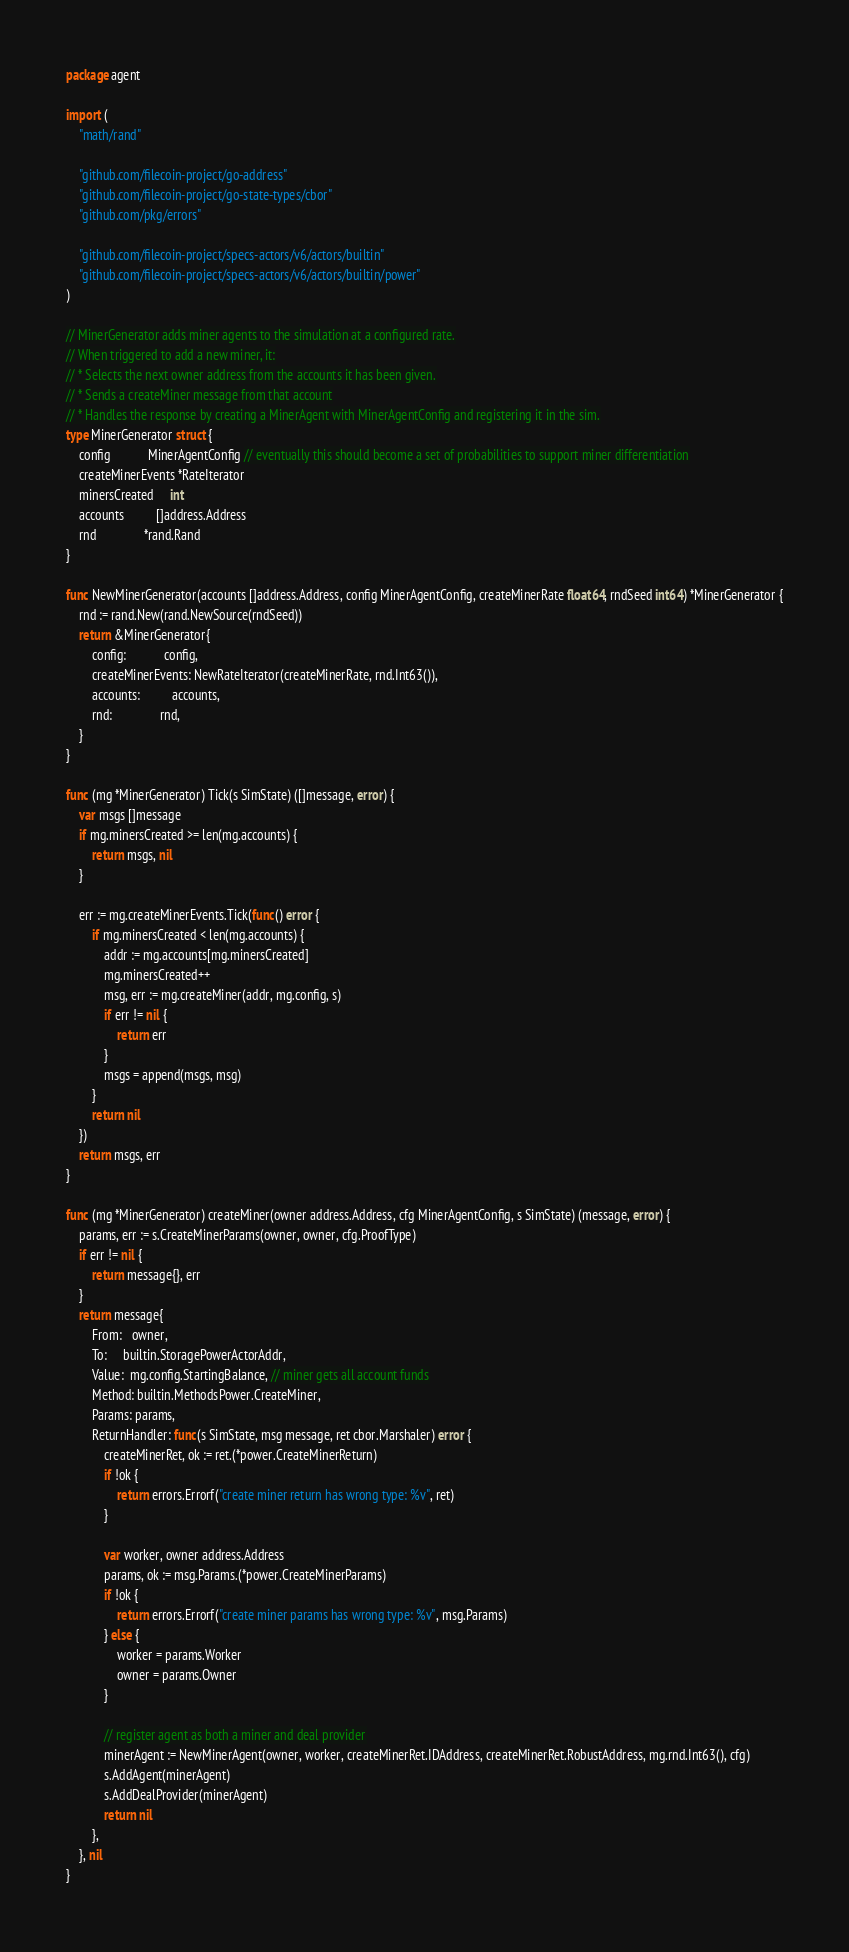Convert code to text. <code><loc_0><loc_0><loc_500><loc_500><_Go_>package agent

import (
	"math/rand"

	"github.com/filecoin-project/go-address"
	"github.com/filecoin-project/go-state-types/cbor"
	"github.com/pkg/errors"

	"github.com/filecoin-project/specs-actors/v6/actors/builtin"
	"github.com/filecoin-project/specs-actors/v6/actors/builtin/power"
)

// MinerGenerator adds miner agents to the simulation at a configured rate.
// When triggered to add a new miner, it:
// * Selects the next owner address from the accounts it has been given.
// * Sends a createMiner message from that account
// * Handles the response by creating a MinerAgent with MinerAgentConfig and registering it in the sim.
type MinerGenerator struct {
	config            MinerAgentConfig // eventually this should become a set of probabilities to support miner differentiation
	createMinerEvents *RateIterator
	minersCreated     int
	accounts          []address.Address
	rnd               *rand.Rand
}

func NewMinerGenerator(accounts []address.Address, config MinerAgentConfig, createMinerRate float64, rndSeed int64) *MinerGenerator {
	rnd := rand.New(rand.NewSource(rndSeed))
	return &MinerGenerator{
		config:            config,
		createMinerEvents: NewRateIterator(createMinerRate, rnd.Int63()),
		accounts:          accounts,
		rnd:               rnd,
	}
}

func (mg *MinerGenerator) Tick(s SimState) ([]message, error) {
	var msgs []message
	if mg.minersCreated >= len(mg.accounts) {
		return msgs, nil
	}

	err := mg.createMinerEvents.Tick(func() error {
		if mg.minersCreated < len(mg.accounts) {
			addr := mg.accounts[mg.minersCreated]
			mg.minersCreated++
			msg, err := mg.createMiner(addr, mg.config, s)
			if err != nil {
				return err
			}
			msgs = append(msgs, msg)
		}
		return nil
	})
	return msgs, err
}

func (mg *MinerGenerator) createMiner(owner address.Address, cfg MinerAgentConfig, s SimState) (message, error) {
	params, err := s.CreateMinerParams(owner, owner, cfg.ProofType)
	if err != nil {
		return message{}, err
	}
	return message{
		From:   owner,
		To:     builtin.StoragePowerActorAddr,
		Value:  mg.config.StartingBalance, // miner gets all account funds
		Method: builtin.MethodsPower.CreateMiner,
		Params: params,
		ReturnHandler: func(s SimState, msg message, ret cbor.Marshaler) error {
			createMinerRet, ok := ret.(*power.CreateMinerReturn)
			if !ok {
				return errors.Errorf("create miner return has wrong type: %v", ret)
			}

			var worker, owner address.Address
			params, ok := msg.Params.(*power.CreateMinerParams)
			if !ok {
				return errors.Errorf("create miner params has wrong type: %v", msg.Params)
			} else {
				worker = params.Worker
				owner = params.Owner
			}

			// register agent as both a miner and deal provider
			minerAgent := NewMinerAgent(owner, worker, createMinerRet.IDAddress, createMinerRet.RobustAddress, mg.rnd.Int63(), cfg)
			s.AddAgent(minerAgent)
			s.AddDealProvider(minerAgent)
			return nil
		},
	}, nil
}
</code> 